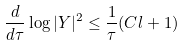<formula> <loc_0><loc_0><loc_500><loc_500>\frac { d } { d \tau } \log | Y | ^ { 2 } \leq \frac { 1 } { \tau } ( C l + 1 )</formula> 